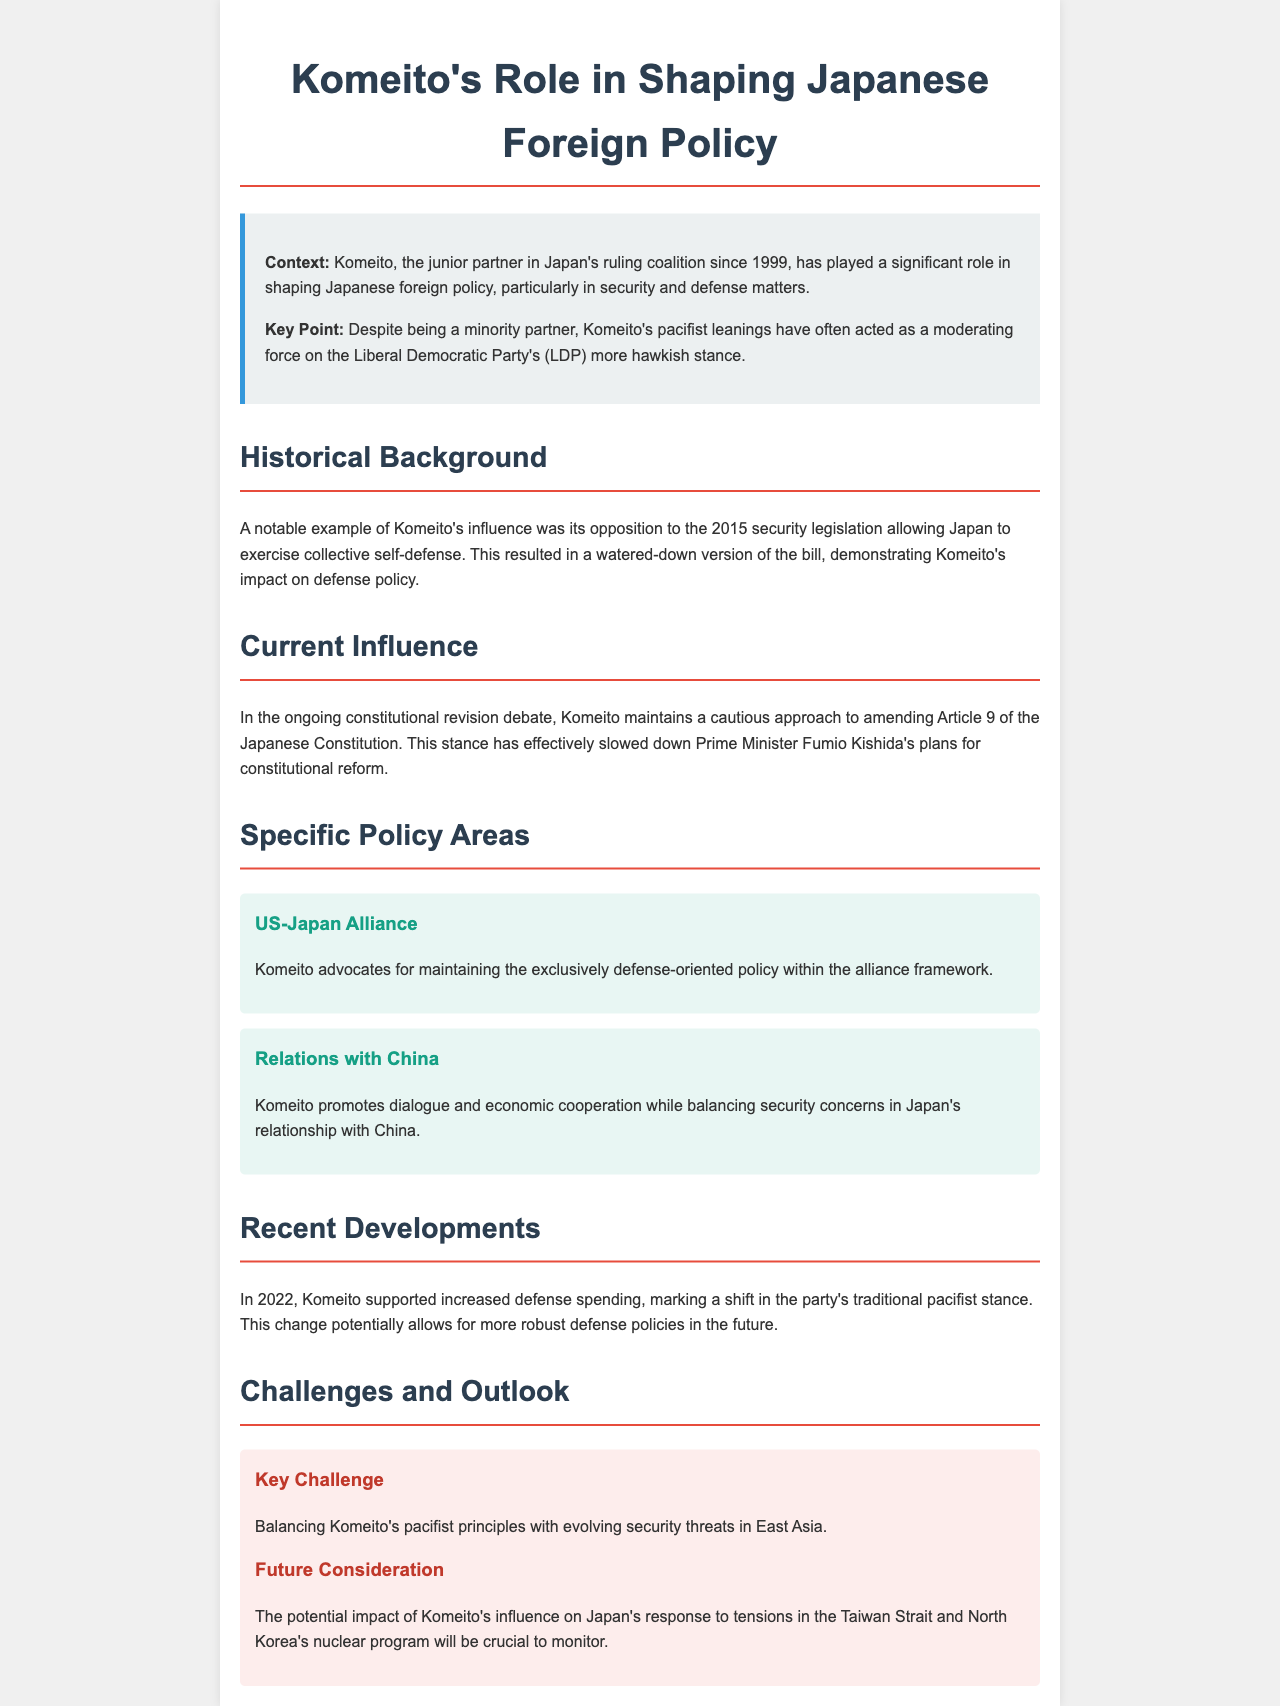What year did Komeito become a junior partner in the ruling coalition? The document states that Komeito has been the junior partner since 1999.
Answer: 1999 What significant legislation did Komeito oppose in 2015? The document mentions Komeito's opposition to the security legislation allowing collective self-defense.
Answer: Security legislation What is Komeito's stance on amending Article 9 of the Japanese Constitution? The document indicates that Komeito maintains a cautious approach to amending Article 9.
Answer: Cautious approach What does Komeito advocate for in the US-Japan alliance? The document states that Komeito advocates for maintaining an exclusively defense-oriented policy within the alliance framework.
Answer: Exclusively defense-oriented policy What major shift occurred in Komeito's stance in 2022? The document notes that Komeito supported increased defense spending, marking a shift from its traditional pacifist stance.
Answer: Increased defense spending What key challenge does Komeito face according to the document? The document identifies balancing Komeito's pacifist principles with evolving security threats in East Asia as a key challenge.
Answer: Balancing pacifist principles What impact is Komeito's influence expected to have regarding tensions in the Taiwan Strait? The document suggests that Komeito's influence will be crucial in Japan's response to tensions in the Taiwan Strait and North Korea's nuclear program.
Answer: Crucial impact 